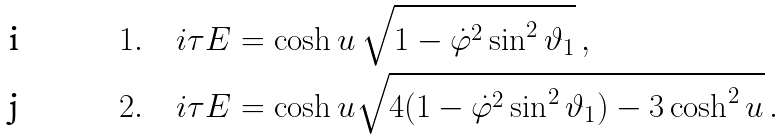<formula> <loc_0><loc_0><loc_500><loc_500>& 1 . \quad i \tau E = \cosh u \, \sqrt { 1 - \dot { \varphi } ^ { 2 } \sin ^ { 2 } \vartheta _ { 1 } } \, , \\ & 2 . \quad i \tau E = \cosh u \sqrt { 4 ( 1 - \dot { \varphi } ^ { 2 } \sin ^ { 2 } \vartheta _ { 1 } ) - 3 \cosh ^ { 2 } u } \, .</formula> 